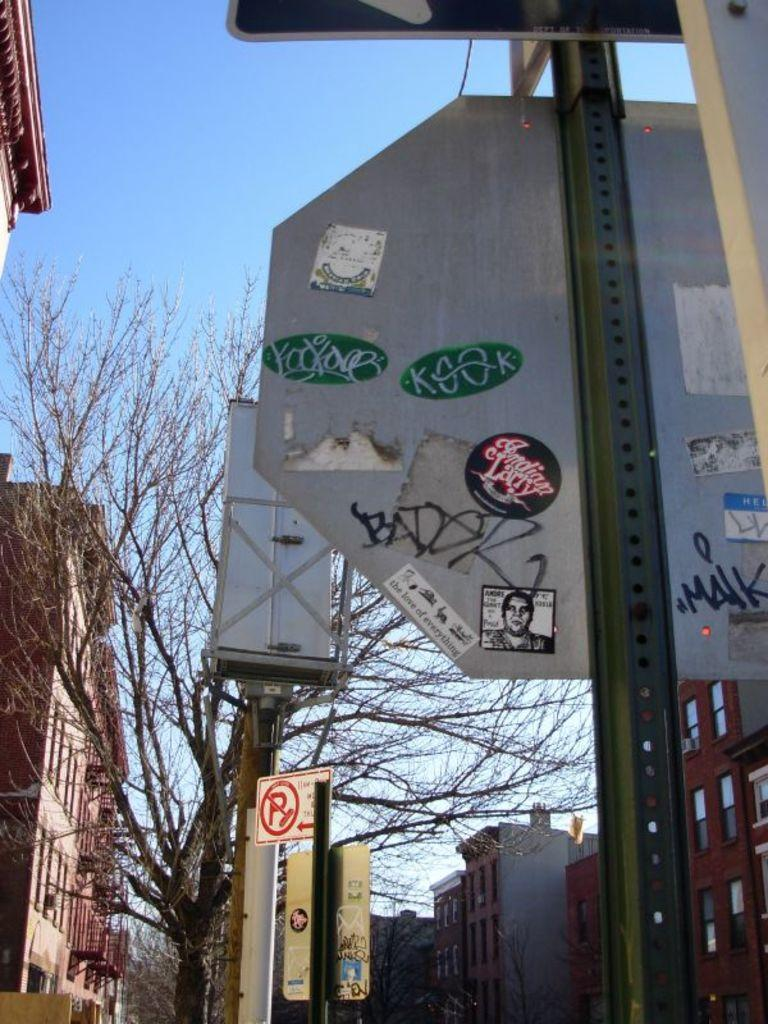What structures are located on the sides of the image? There are buildings on either side of the image. What can be seen in the middle of the image? There are trees and caution boards in the middle of the image. What is visible above the image? The sky is visible above the image. How many pets can be seen in the image? There are no pets present in the image. What type of lock is used on the caution boards in the image? There are no locks visible on the caution boards in the image. 